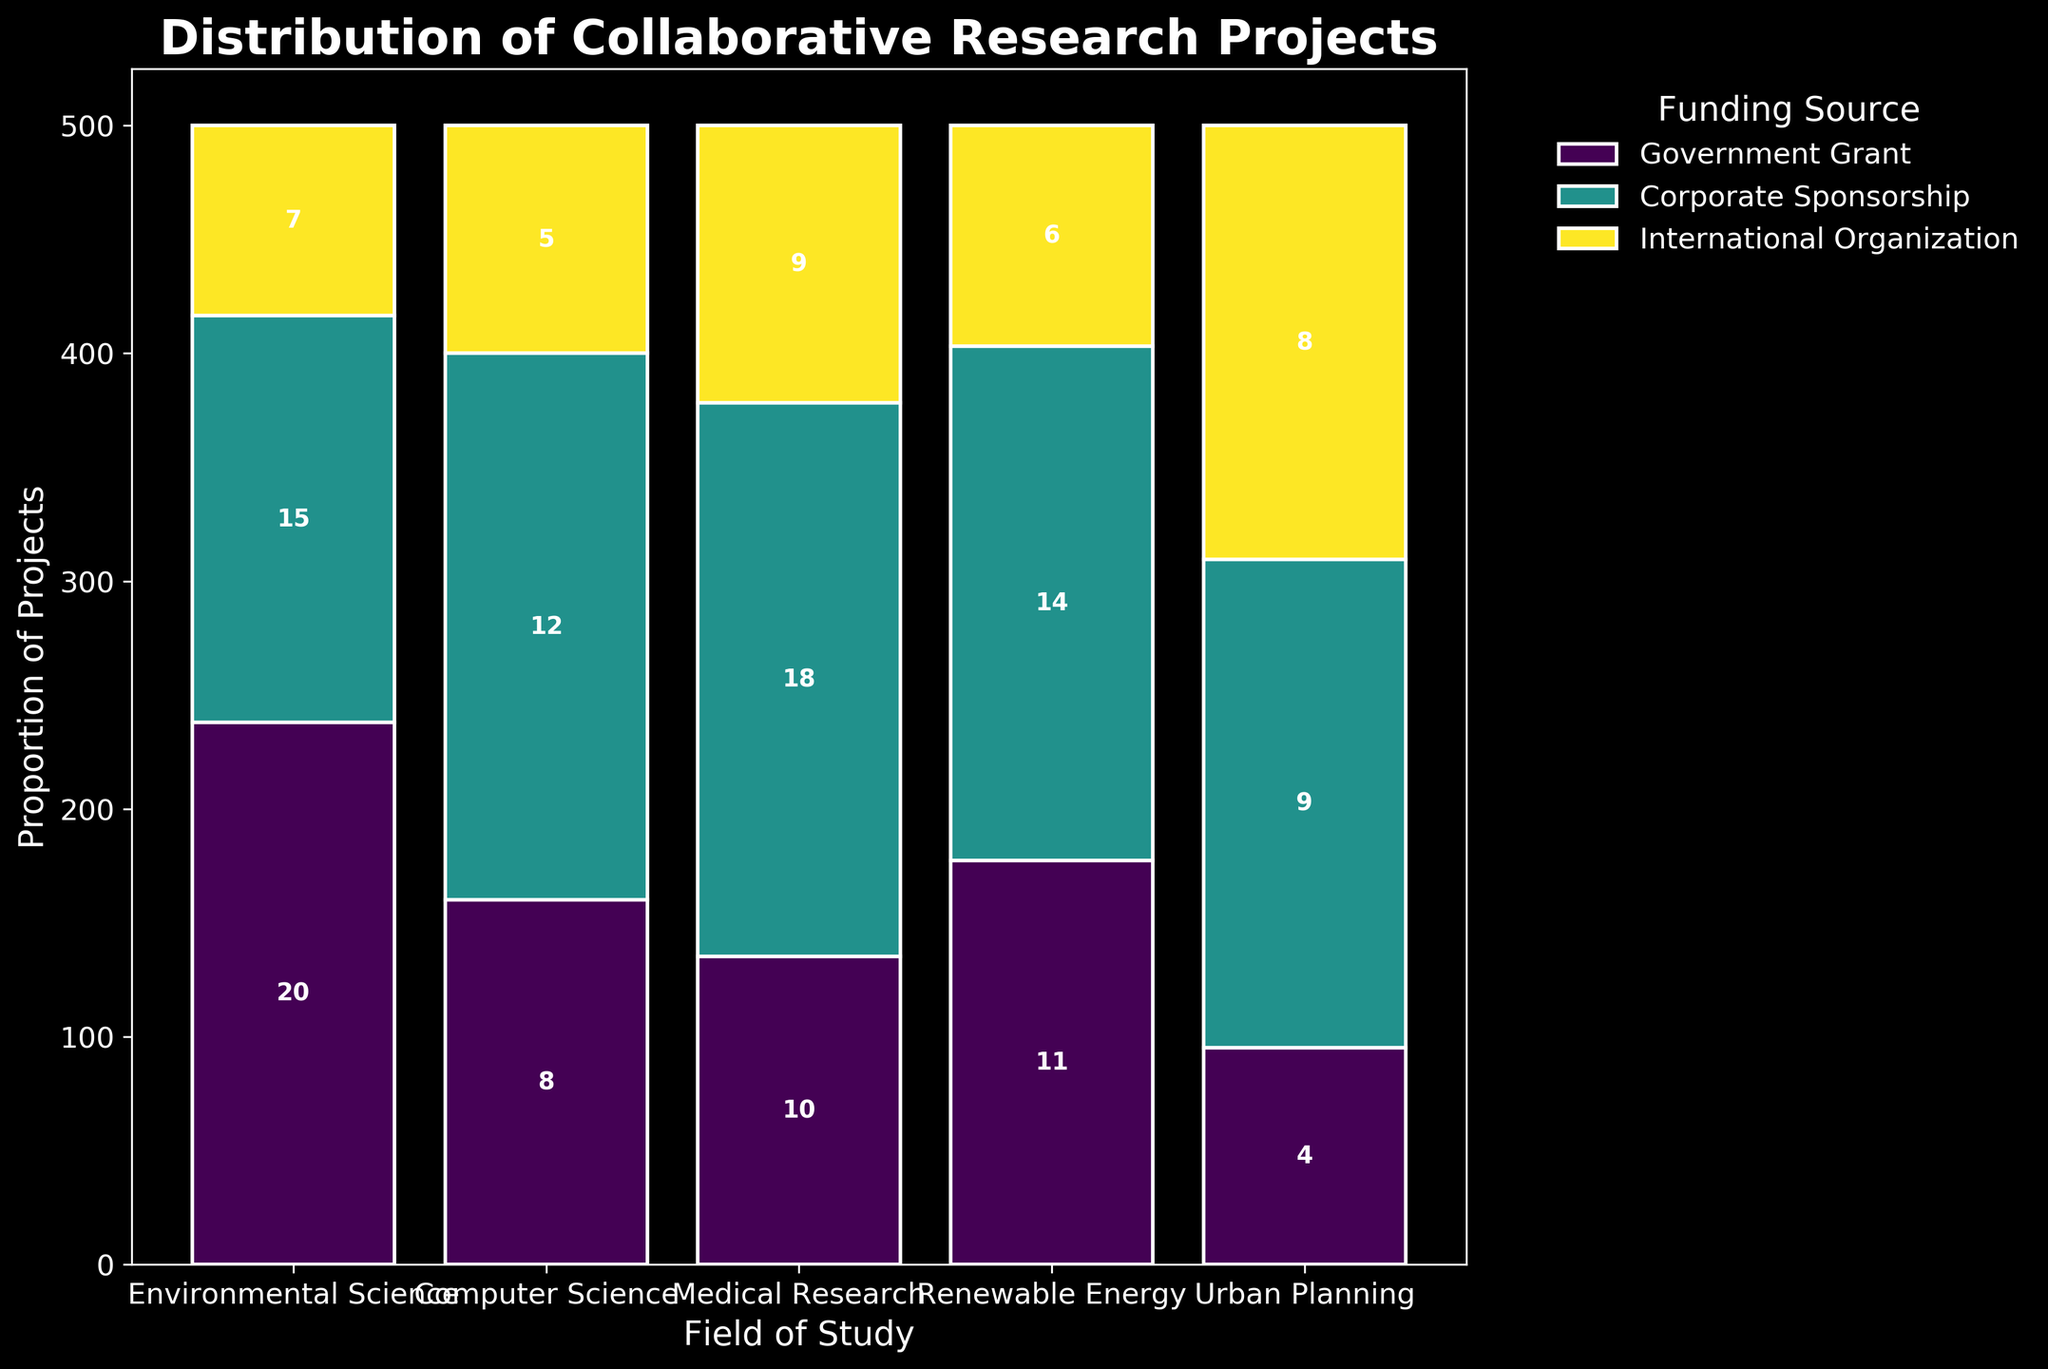What is the title of the figure? The title is usually a prominent text at the top of the figure.
Answer: Distribution of Collaborative Research Projects Which field has the highest number of projects funded by government grants? By looking at the heights of the bars within each field colored to represent government grants, the tallest bar indicates the highest number.
Answer: Medical Research How many projects in Urban Planning are funded by international organizations? Find the bar segment specifically representing international organizations within the Urban Planning field and read the corresponding label.
Answer: 8 What proportion of projects in Computer Science is funded by corporate sponsorship? Calculate the height of the bar segment for corporate sponsorship in Computer Science and divide it by the total height of all segments in Computer Science.
Answer: 20/42 = 0.476 Which funding source has the lowest representation in Environmental Science? Compare the heights of the three segments within Environmental Science, and the shortest segment will indicate the lowest representation.
Answer: International Organization What is the total number of projects funded by government grants? Sum the number of projects funded by government grants across all fields.
Answer: 12 + 15 + 18 + 14 + 9 = 68 How does the number of projects funded by corporate sponsorship compare between Computer Science and Medical Research? Compare the heights and values of the corporate sponsorship segments in both fields.
Answer: Computer Science (20) > Medical Research (10) In which field do international organizations have the highest number of projects? Compare all fields and identify the tallest segment for international organizations.
Answer: Medical Research What is the average number of projects funded by international organizations across all fields? Sum the number of projects funded by international organizations across all fields and divide by the number of fields.
Answer: (5 + 7 + 9 + 6 + 8) / 5 = 7 Which field has the most evenly distributed funding sources? Evaluate each field’s segment heights for similarity. The more even they are, the more evenly distributed the funding sources are.
Answer: Urban Planning 